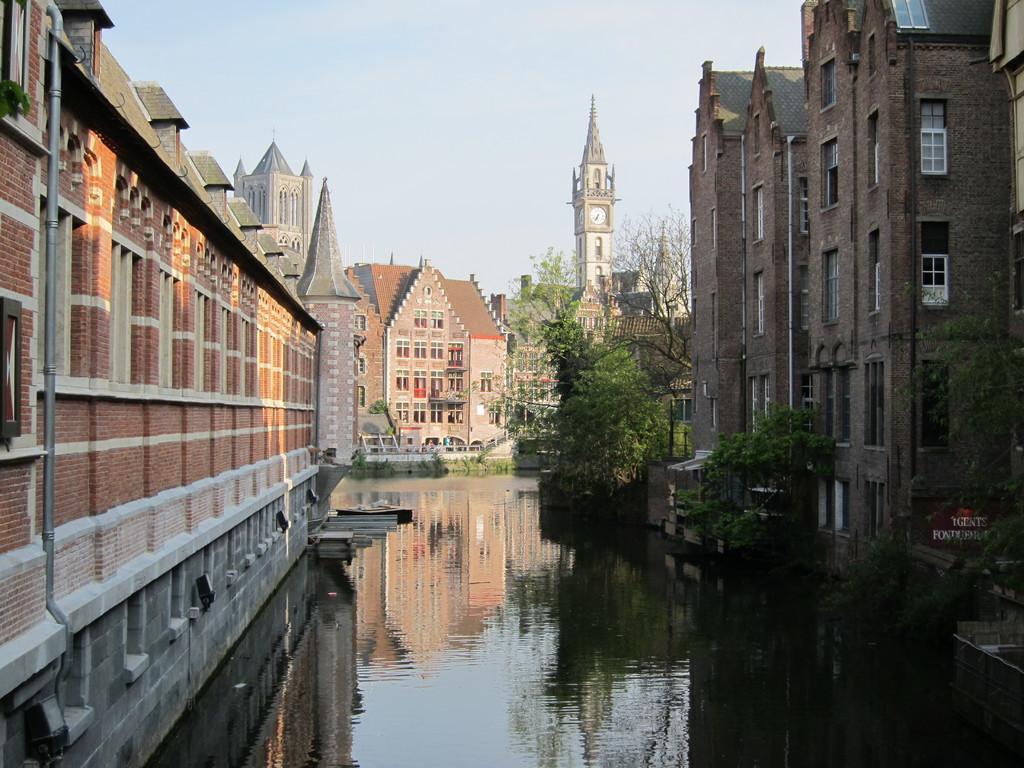Could you give a brief overview of what you see in this image? In this image I can see the water. To the side of the water I can see many trees and the buildings. I can see the board to the right. In the background I can see the sky. 